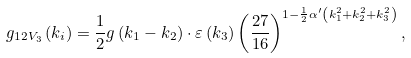<formula> <loc_0><loc_0><loc_500><loc_500>g _ { 1 2 V _ { 3 } } \left ( k _ { i } \right ) = \frac { 1 } { 2 } g \left ( k _ { 1 } - k _ { 2 } \right ) \cdot \varepsilon \left ( k _ { 3 } \right ) \left ( \frac { 2 7 } { 1 6 } \right ) ^ { 1 - \frac { 1 } { 2 } \alpha ^ { \prime } \left ( k _ { 1 } ^ { 2 } + k _ { 2 } ^ { 2 } + k _ { 3 } ^ { 2 } \right ) } ,</formula> 